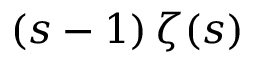<formula> <loc_0><loc_0><loc_500><loc_500>( s - 1 ) \, \zeta ( s )</formula> 